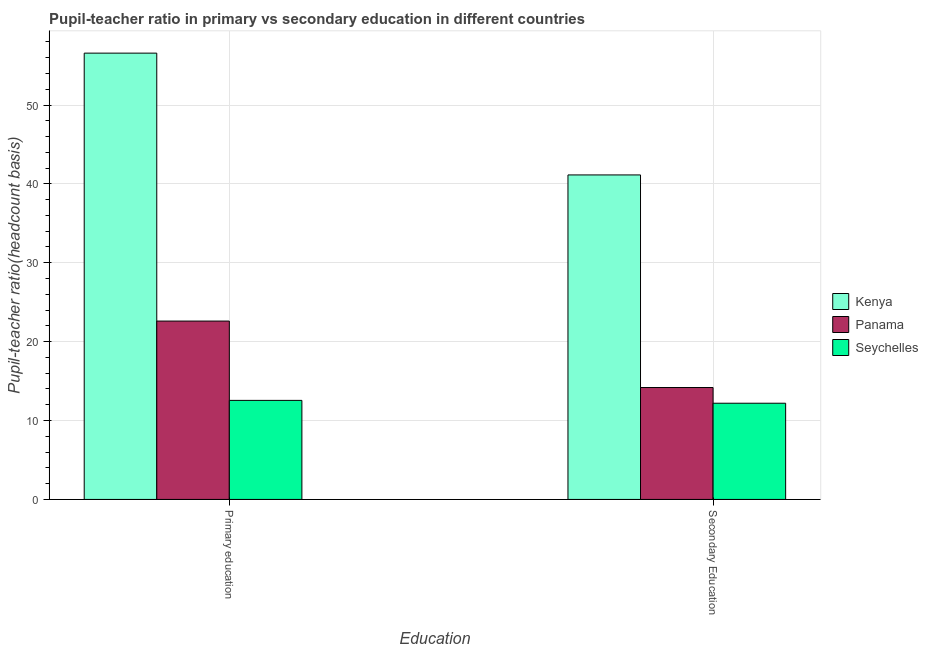How many different coloured bars are there?
Offer a very short reply. 3. How many groups of bars are there?
Your answer should be compact. 2. How many bars are there on the 1st tick from the left?
Your response must be concise. 3. How many bars are there on the 1st tick from the right?
Provide a short and direct response. 3. What is the label of the 2nd group of bars from the left?
Give a very brief answer. Secondary Education. What is the pupil teacher ratio on secondary education in Seychelles?
Your answer should be compact. 12.19. Across all countries, what is the maximum pupil-teacher ratio in primary education?
Make the answer very short. 56.57. Across all countries, what is the minimum pupil-teacher ratio in primary education?
Provide a succinct answer. 12.56. In which country was the pupil teacher ratio on secondary education maximum?
Make the answer very short. Kenya. In which country was the pupil-teacher ratio in primary education minimum?
Offer a terse response. Seychelles. What is the total pupil teacher ratio on secondary education in the graph?
Keep it short and to the point. 67.51. What is the difference between the pupil teacher ratio on secondary education in Seychelles and that in Panama?
Your response must be concise. -1.99. What is the difference between the pupil-teacher ratio in primary education in Seychelles and the pupil teacher ratio on secondary education in Panama?
Your response must be concise. -1.63. What is the average pupil-teacher ratio in primary education per country?
Make the answer very short. 30.58. What is the difference between the pupil teacher ratio on secondary education and pupil-teacher ratio in primary education in Kenya?
Provide a succinct answer. -15.44. In how many countries, is the pupil teacher ratio on secondary education greater than 48 ?
Offer a terse response. 0. What is the ratio of the pupil teacher ratio on secondary education in Seychelles to that in Panama?
Provide a short and direct response. 0.86. What does the 3rd bar from the left in Secondary Education represents?
Offer a terse response. Seychelles. What does the 1st bar from the right in Secondary Education represents?
Provide a succinct answer. Seychelles. How many bars are there?
Provide a short and direct response. 6. How many countries are there in the graph?
Your answer should be very brief. 3. What is the difference between two consecutive major ticks on the Y-axis?
Your response must be concise. 10. Does the graph contain any zero values?
Ensure brevity in your answer.  No. Does the graph contain grids?
Your response must be concise. Yes. Where does the legend appear in the graph?
Give a very brief answer. Center right. How are the legend labels stacked?
Ensure brevity in your answer.  Vertical. What is the title of the graph?
Your answer should be very brief. Pupil-teacher ratio in primary vs secondary education in different countries. What is the label or title of the X-axis?
Keep it short and to the point. Education. What is the label or title of the Y-axis?
Your answer should be compact. Pupil-teacher ratio(headcount basis). What is the Pupil-teacher ratio(headcount basis) in Kenya in Primary education?
Ensure brevity in your answer.  56.57. What is the Pupil-teacher ratio(headcount basis) in Panama in Primary education?
Provide a short and direct response. 22.61. What is the Pupil-teacher ratio(headcount basis) of Seychelles in Primary education?
Make the answer very short. 12.56. What is the Pupil-teacher ratio(headcount basis) of Kenya in Secondary Education?
Offer a very short reply. 41.13. What is the Pupil-teacher ratio(headcount basis) of Panama in Secondary Education?
Offer a very short reply. 14.18. What is the Pupil-teacher ratio(headcount basis) in Seychelles in Secondary Education?
Offer a terse response. 12.19. Across all Education, what is the maximum Pupil-teacher ratio(headcount basis) in Kenya?
Offer a very short reply. 56.57. Across all Education, what is the maximum Pupil-teacher ratio(headcount basis) of Panama?
Provide a short and direct response. 22.61. Across all Education, what is the maximum Pupil-teacher ratio(headcount basis) in Seychelles?
Provide a succinct answer. 12.56. Across all Education, what is the minimum Pupil-teacher ratio(headcount basis) of Kenya?
Offer a very short reply. 41.13. Across all Education, what is the minimum Pupil-teacher ratio(headcount basis) of Panama?
Provide a short and direct response. 14.18. Across all Education, what is the minimum Pupil-teacher ratio(headcount basis) of Seychelles?
Ensure brevity in your answer.  12.19. What is the total Pupil-teacher ratio(headcount basis) of Kenya in the graph?
Your response must be concise. 97.71. What is the total Pupil-teacher ratio(headcount basis) of Panama in the graph?
Keep it short and to the point. 36.79. What is the total Pupil-teacher ratio(headcount basis) of Seychelles in the graph?
Your answer should be compact. 24.75. What is the difference between the Pupil-teacher ratio(headcount basis) in Kenya in Primary education and that in Secondary Education?
Offer a terse response. 15.44. What is the difference between the Pupil-teacher ratio(headcount basis) in Panama in Primary education and that in Secondary Education?
Keep it short and to the point. 8.43. What is the difference between the Pupil-teacher ratio(headcount basis) of Seychelles in Primary education and that in Secondary Education?
Give a very brief answer. 0.36. What is the difference between the Pupil-teacher ratio(headcount basis) in Kenya in Primary education and the Pupil-teacher ratio(headcount basis) in Panama in Secondary Education?
Offer a very short reply. 42.39. What is the difference between the Pupil-teacher ratio(headcount basis) of Kenya in Primary education and the Pupil-teacher ratio(headcount basis) of Seychelles in Secondary Education?
Make the answer very short. 44.38. What is the difference between the Pupil-teacher ratio(headcount basis) in Panama in Primary education and the Pupil-teacher ratio(headcount basis) in Seychelles in Secondary Education?
Provide a succinct answer. 10.42. What is the average Pupil-teacher ratio(headcount basis) of Kenya per Education?
Offer a terse response. 48.85. What is the average Pupil-teacher ratio(headcount basis) of Panama per Education?
Make the answer very short. 18.4. What is the average Pupil-teacher ratio(headcount basis) of Seychelles per Education?
Offer a very short reply. 12.38. What is the difference between the Pupil-teacher ratio(headcount basis) in Kenya and Pupil-teacher ratio(headcount basis) in Panama in Primary education?
Your answer should be very brief. 33.96. What is the difference between the Pupil-teacher ratio(headcount basis) in Kenya and Pupil-teacher ratio(headcount basis) in Seychelles in Primary education?
Provide a short and direct response. 44.02. What is the difference between the Pupil-teacher ratio(headcount basis) in Panama and Pupil-teacher ratio(headcount basis) in Seychelles in Primary education?
Ensure brevity in your answer.  10.05. What is the difference between the Pupil-teacher ratio(headcount basis) in Kenya and Pupil-teacher ratio(headcount basis) in Panama in Secondary Education?
Your answer should be compact. 26.95. What is the difference between the Pupil-teacher ratio(headcount basis) of Kenya and Pupil-teacher ratio(headcount basis) of Seychelles in Secondary Education?
Ensure brevity in your answer.  28.94. What is the difference between the Pupil-teacher ratio(headcount basis) in Panama and Pupil-teacher ratio(headcount basis) in Seychelles in Secondary Education?
Your answer should be very brief. 1.99. What is the ratio of the Pupil-teacher ratio(headcount basis) of Kenya in Primary education to that in Secondary Education?
Keep it short and to the point. 1.38. What is the ratio of the Pupil-teacher ratio(headcount basis) of Panama in Primary education to that in Secondary Education?
Your answer should be very brief. 1.59. What is the ratio of the Pupil-teacher ratio(headcount basis) of Seychelles in Primary education to that in Secondary Education?
Your answer should be very brief. 1.03. What is the difference between the highest and the second highest Pupil-teacher ratio(headcount basis) in Kenya?
Offer a terse response. 15.44. What is the difference between the highest and the second highest Pupil-teacher ratio(headcount basis) of Panama?
Make the answer very short. 8.43. What is the difference between the highest and the second highest Pupil-teacher ratio(headcount basis) in Seychelles?
Provide a short and direct response. 0.36. What is the difference between the highest and the lowest Pupil-teacher ratio(headcount basis) of Kenya?
Give a very brief answer. 15.44. What is the difference between the highest and the lowest Pupil-teacher ratio(headcount basis) of Panama?
Provide a succinct answer. 8.43. What is the difference between the highest and the lowest Pupil-teacher ratio(headcount basis) in Seychelles?
Provide a succinct answer. 0.36. 